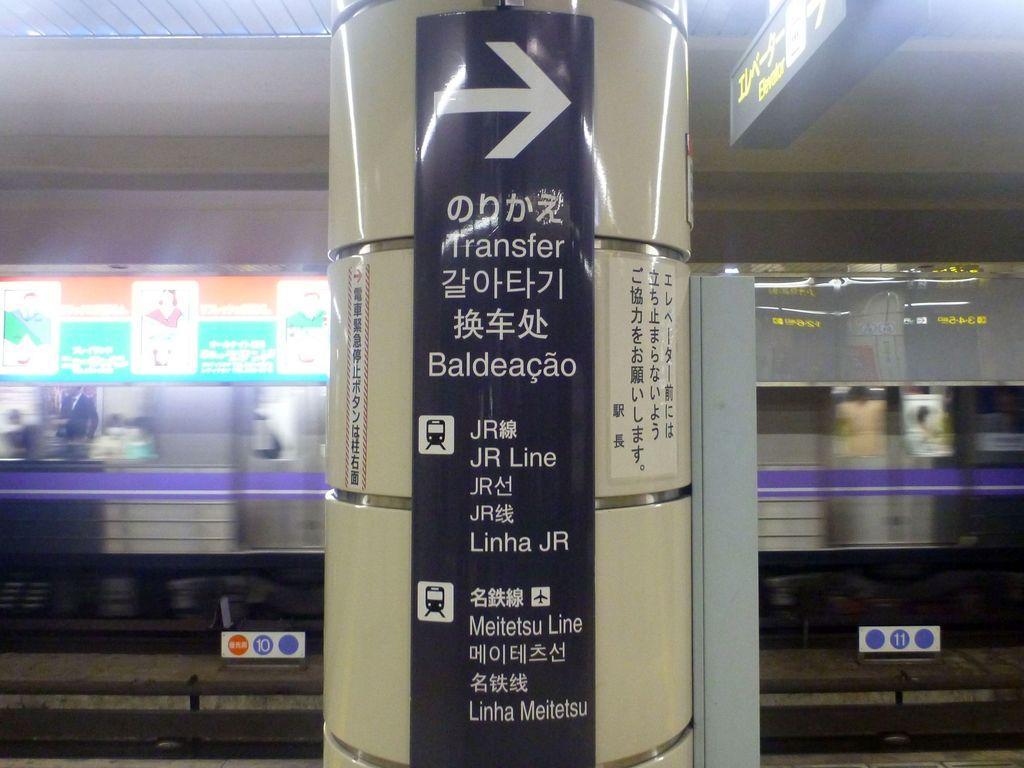<image>
Give a short and clear explanation of the subsequent image. A subway station that shows a pillar with information in Chinese 